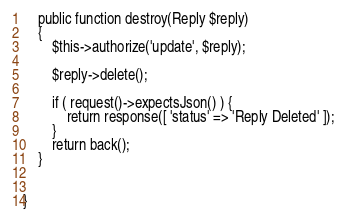<code> <loc_0><loc_0><loc_500><loc_500><_PHP_>
    public function destroy(Reply $reply)
    {
        $this->authorize('update', $reply);

        $reply->delete();

        if ( request()->expectsJson() ) {
            return response([ 'status' => 'Reply Deleted' ]);
        }
        return back();
    }


}
</code> 